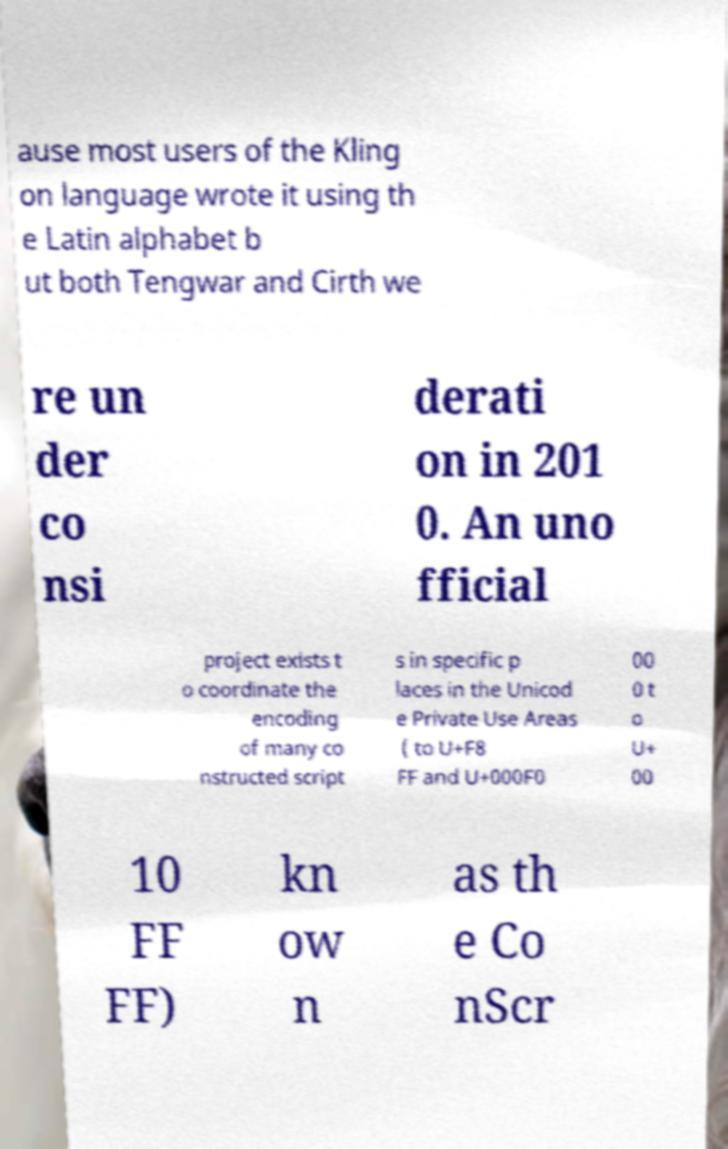Can you accurately transcribe the text from the provided image for me? ause most users of the Kling on language wrote it using th e Latin alphabet b ut both Tengwar and Cirth we re un der co nsi derati on in 201 0. An uno fficial project exists t o coordinate the encoding of many co nstructed script s in specific p laces in the Unicod e Private Use Areas ( to U+F8 FF and U+000F0 00 0 t o U+ 00 10 FF FF) kn ow n as th e Co nScr 